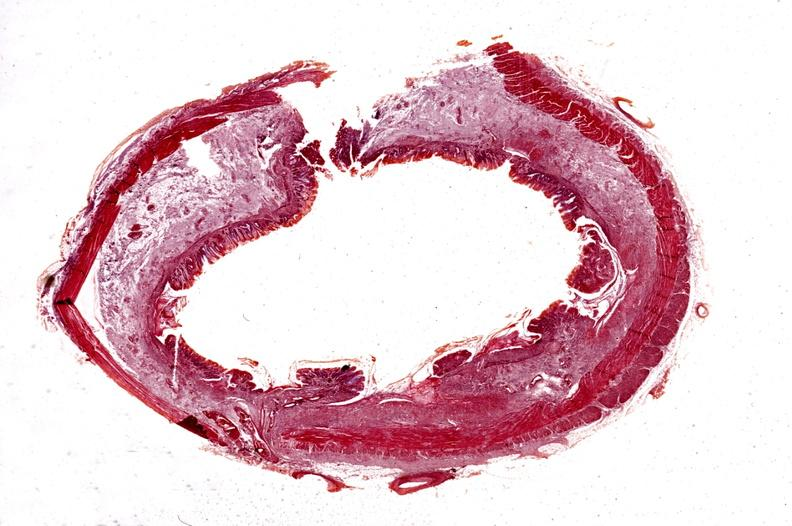s edema present?
Answer the question using a single word or phrase. No 